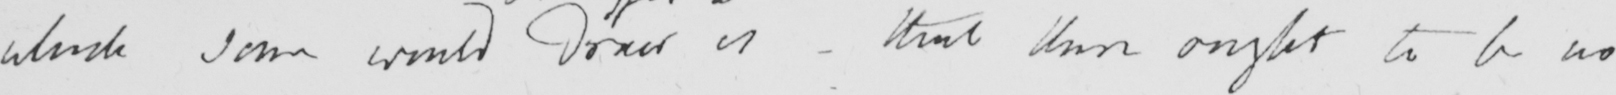Can you read and transcribe this handwriting? which some would  <gap/>  is - that there ought to be no 